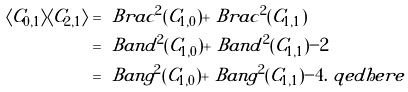Convert formula to latex. <formula><loc_0><loc_0><loc_500><loc_500>\langle C _ { 0 , 1 } \rangle \langle C _ { 2 , 1 } \rangle & = \ B r a c ^ { 2 } ( C _ { 1 , 0 } ) + \ B r a c ^ { 2 } ( C _ { 1 , 1 } ) \\ & = \ B a n d ^ { 2 } ( C _ { 1 , 0 } ) + \ B a n d ^ { 2 } ( C _ { 1 , 1 } ) - 2 \\ & = \ B a n g ^ { 2 } ( C _ { 1 , 0 } ) + \ B a n g ^ { 2 } ( C _ { 1 , 1 } ) - 4 . \ q e d h e r e</formula> 